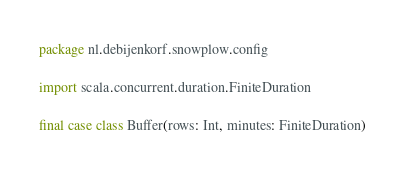<code> <loc_0><loc_0><loc_500><loc_500><_Scala_>package nl.debijenkorf.snowplow.config

import scala.concurrent.duration.FiniteDuration

final case class Buffer(rows: Int, minutes: FiniteDuration)
</code> 